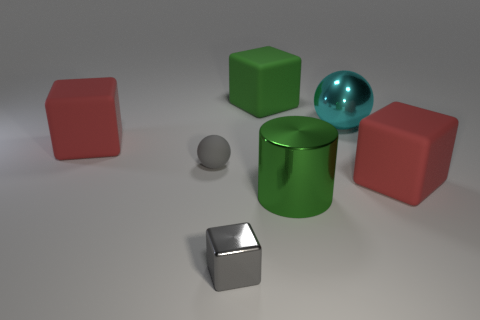Subtract all yellow cylinders. Subtract all blue blocks. How many cylinders are left? 1 Add 1 large cyan rubber cylinders. How many objects exist? 8 Subtract all spheres. How many objects are left? 5 Add 3 red matte blocks. How many red matte blocks are left? 5 Add 4 gray blocks. How many gray blocks exist? 5 Subtract 0 green spheres. How many objects are left? 7 Subtract all small metal things. Subtract all rubber cubes. How many objects are left? 3 